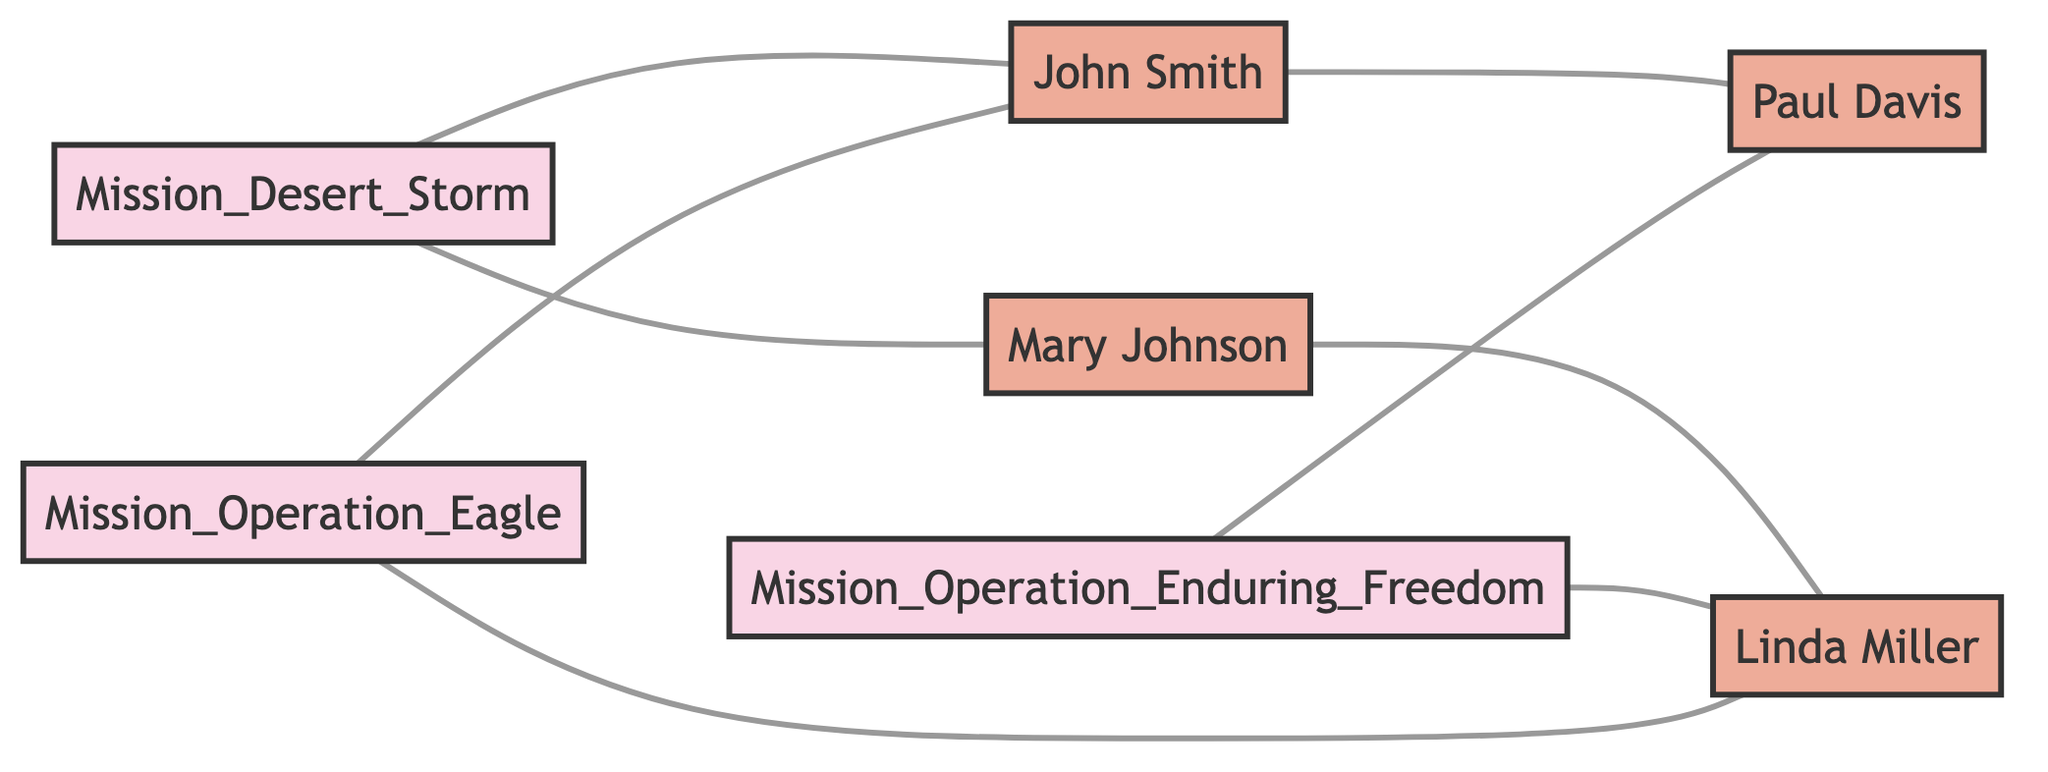What are the total number of missions depicted in the diagram? The diagram shows three mission nodes: Mission Operation Eagle, Mission Desert Storm, and Mission Operation Enduring Freedom. Counting these nodes provides the total number of missions: 3.
Answer: 3 Who participated in Mission Operation Eagle? The diagram includes two connections for Mission Operation Eagle: one to John Smith and another to Linda Miller. Both nodes indicate participation in this mission.
Answer: John Smith and Linda Miller What type of relationship exists between Mary Johnson and Linda Miller? The diagram shows a direct connection between Mary Johnson and Linda Miller labeled "Teamwork." This indicates a collaborative relationship during missions.
Answer: Teamwork Which crewmate provided ground support in Operation Enduring Freedom? Looking at the connection between Mission Operation Enduring Freedom and the crewmates, it is clear that Paul Davis is connected with the label of "Support" for this mission.
Answer: Paul Davis How many total relationships are displayed in the diagram? Counting all the edges (relationships) connecting the nodes in the diagram, there are 8 distinct relationships connecting missions and crewmates.
Answer: 8 What mission involved John Smith coordinating navigation and bombing runs? The diagram indicates a connection between John Smith and Mission Desert Storm specifically related to coordination of navigation and bombing runs during this mission.
Answer: Mission Desert Storm Which crewmate had a relationship of "Friendship" with John Smith? The diagram highlights a direct connection between John Smith and Paul Davis, labeled "Friendship," indicating a long-standing bond between the two.
Answer: Paul Davis How many crewmates worked on Mission Desert Storm? The connections from Mission Desert Storm indicate participation from two crewmates: Mary Johnson and John Smith. Thus, the total number of crewmates for this mission is 2.
Answer: 2 What role did Linda Miller play in Mission Operation Enduring Freedom? The diagram indicates that Linda Miller provided a "Communication" role, establishing reliable communication for the success of Mission Operation Enduring Freedom.
Answer: Communication 